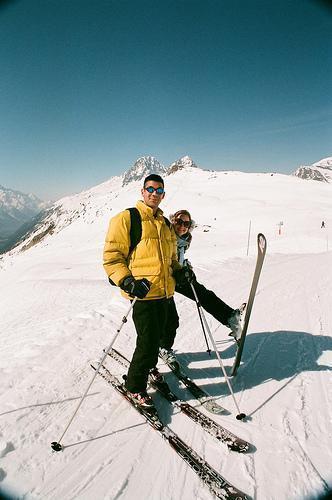How many skis are level against the snow?
Give a very brief answer. 3. 